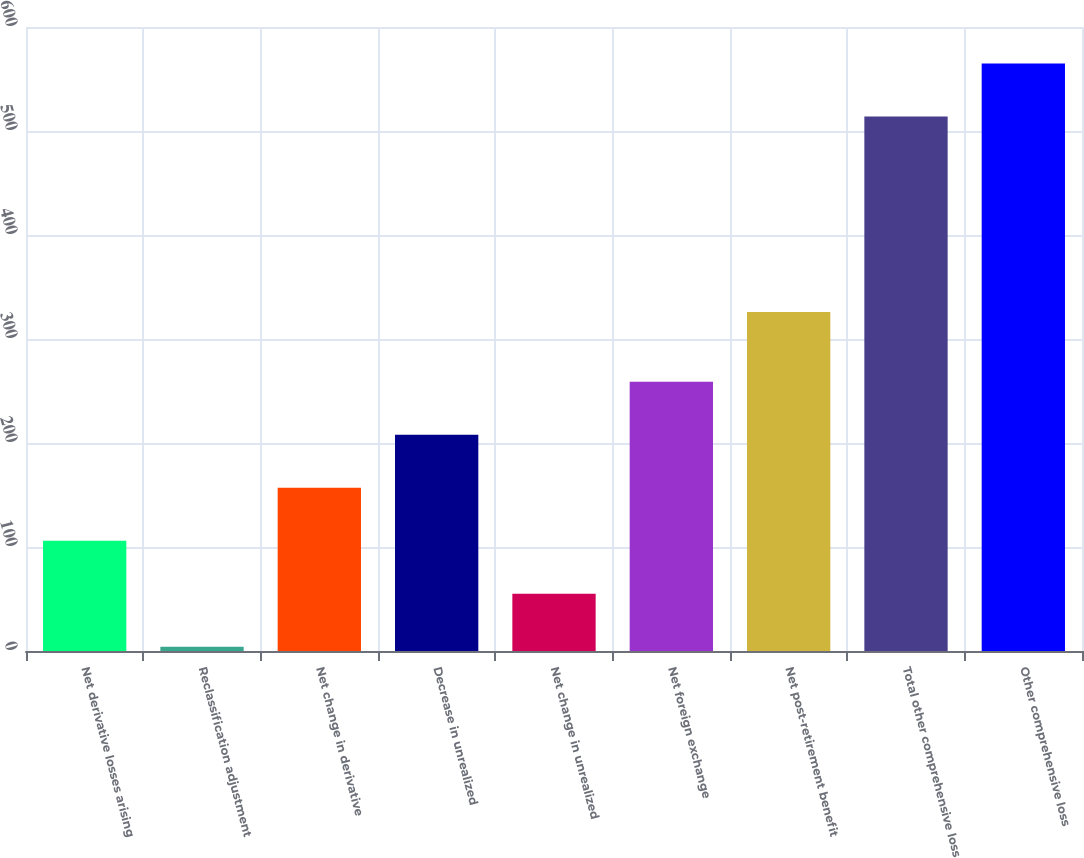<chart> <loc_0><loc_0><loc_500><loc_500><bar_chart><fcel>Net derivative losses arising<fcel>Reclassification adjustment<fcel>Net change in derivative<fcel>Decrease in unrealized<fcel>Net change in unrealized<fcel>Net foreign exchange<fcel>Net post-retirement benefit<fcel>Total other comprehensive loss<fcel>Other comprehensive loss<nl><fcel>106<fcel>4<fcel>157<fcel>208<fcel>55<fcel>259<fcel>326<fcel>514<fcel>565<nl></chart> 